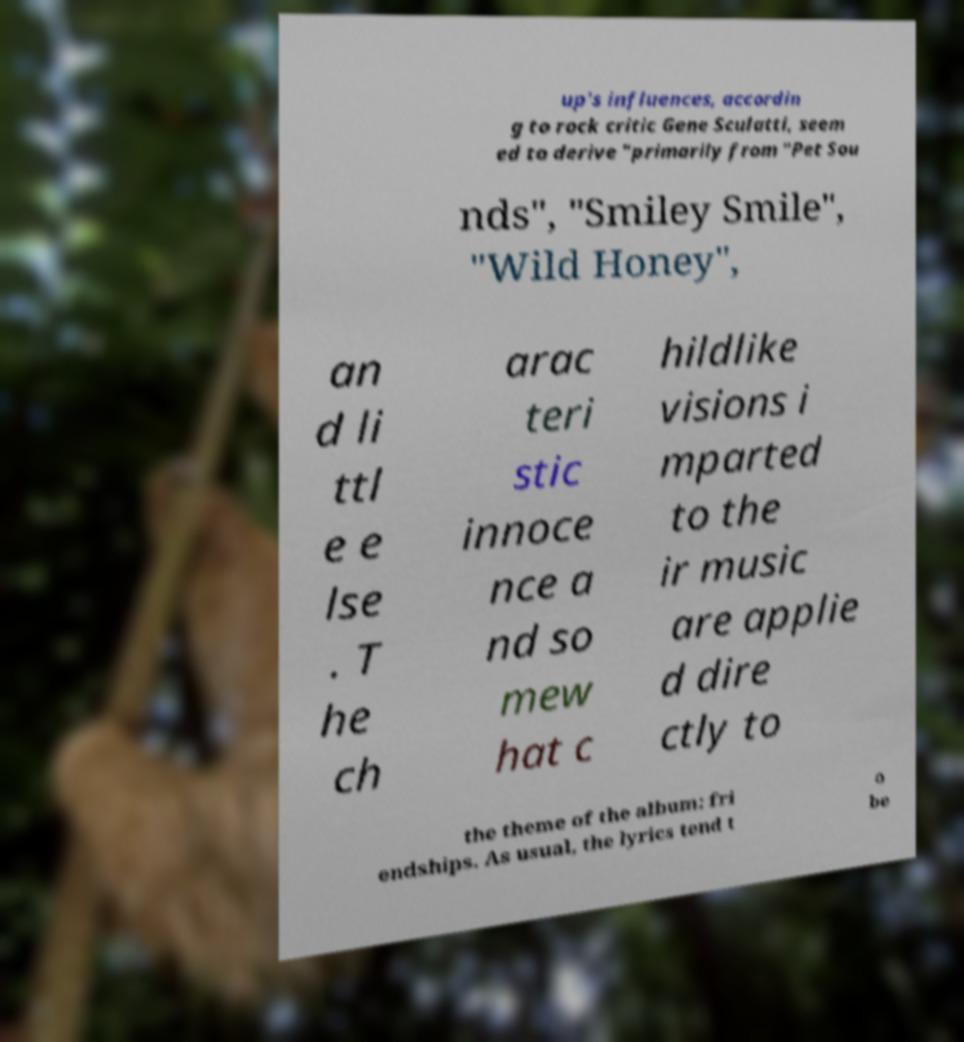What messages or text are displayed in this image? I need them in a readable, typed format. up's influences, accordin g to rock critic Gene Sculatti, seem ed to derive "primarily from "Pet Sou nds", "Smiley Smile", "Wild Honey", an d li ttl e e lse . T he ch arac teri stic innoce nce a nd so mew hat c hildlike visions i mparted to the ir music are applie d dire ctly to the theme of the album: fri endships. As usual, the lyrics tend t o be 